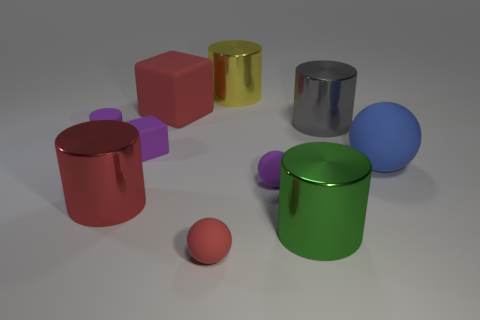Subtract all small cylinders. How many cylinders are left? 4 Subtract all gray cylinders. How many cylinders are left? 4 Subtract 1 balls. How many balls are left? 2 Subtract all blocks. How many objects are left? 8 Add 3 small rubber balls. How many small rubber balls are left? 5 Add 3 big cylinders. How many big cylinders exist? 7 Subtract 0 cyan cubes. How many objects are left? 10 Subtract all yellow spheres. Subtract all brown cylinders. How many spheres are left? 3 Subtract all shiny blocks. Subtract all small cylinders. How many objects are left? 9 